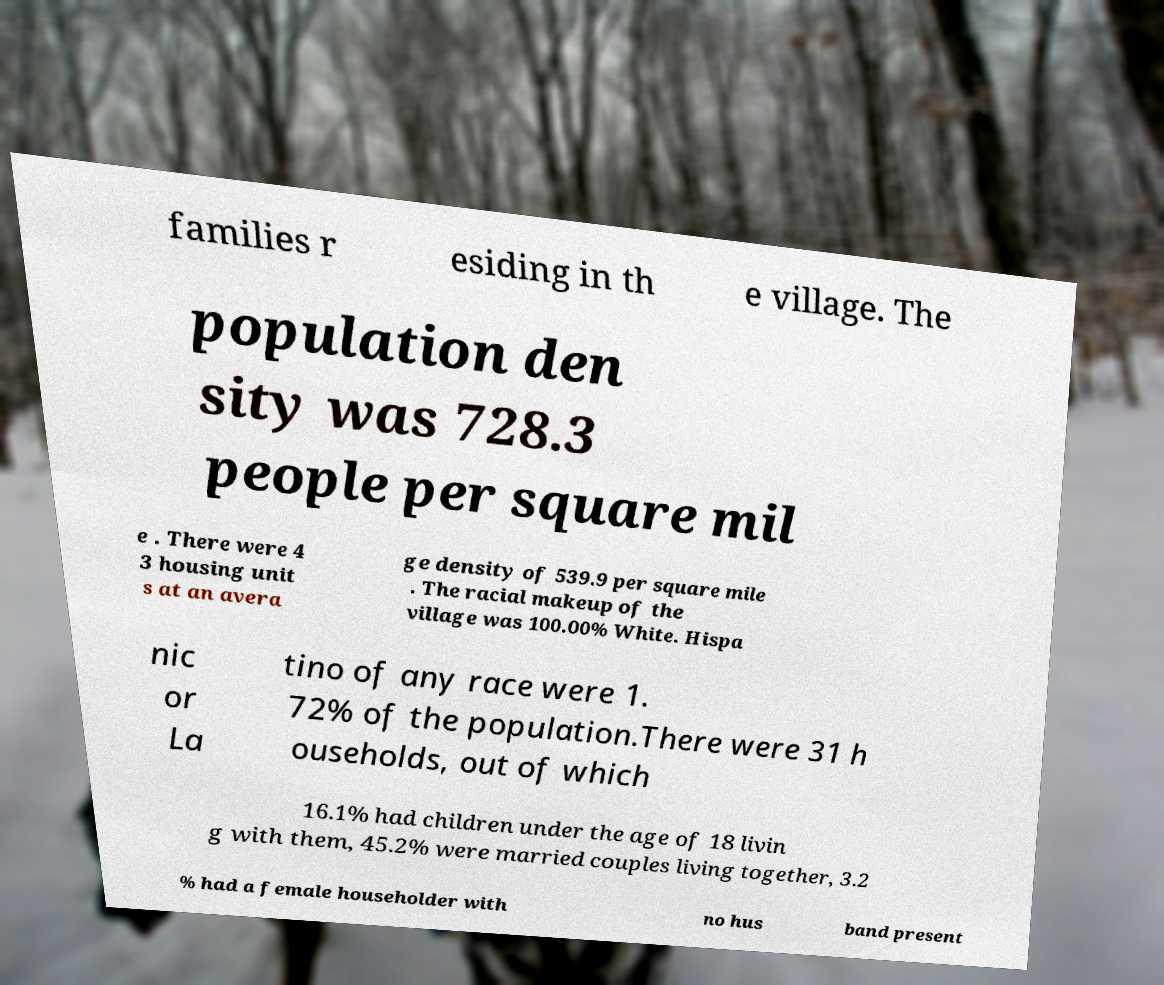What messages or text are displayed in this image? I need them in a readable, typed format. families r esiding in th e village. The population den sity was 728.3 people per square mil e . There were 4 3 housing unit s at an avera ge density of 539.9 per square mile . The racial makeup of the village was 100.00% White. Hispa nic or La tino of any race were 1. 72% of the population.There were 31 h ouseholds, out of which 16.1% had children under the age of 18 livin g with them, 45.2% were married couples living together, 3.2 % had a female householder with no hus band present 